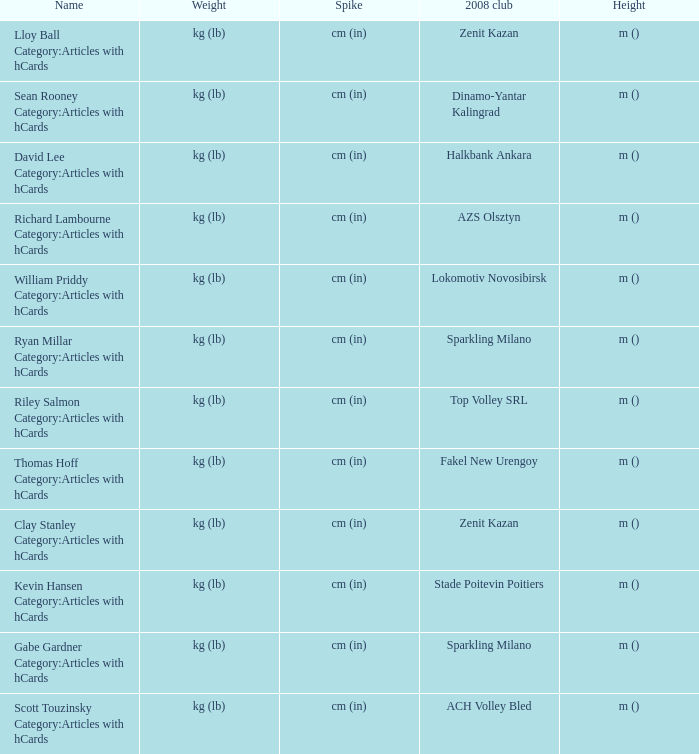What shows for height for the 2008 club of Stade Poitevin Poitiers? M (). 